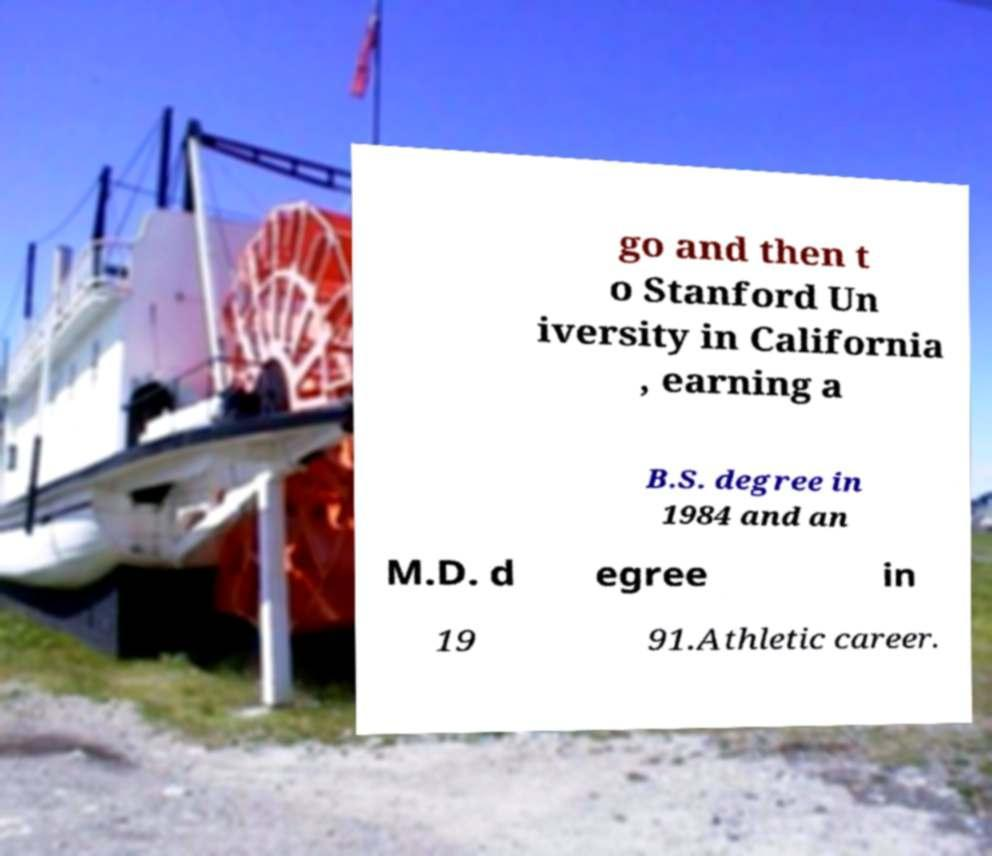Please identify and transcribe the text found in this image. go and then t o Stanford Un iversity in California , earning a B.S. degree in 1984 and an M.D. d egree in 19 91.Athletic career. 